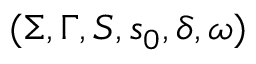Convert formula to latex. <formula><loc_0><loc_0><loc_500><loc_500>( \Sigma , \Gamma , S , s _ { 0 } , \delta , \omega )</formula> 